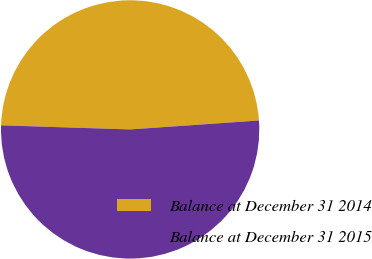Convert chart. <chart><loc_0><loc_0><loc_500><loc_500><pie_chart><fcel>Balance at December 31 2014<fcel>Balance at December 31 2015<nl><fcel>48.39%<fcel>51.61%<nl></chart> 